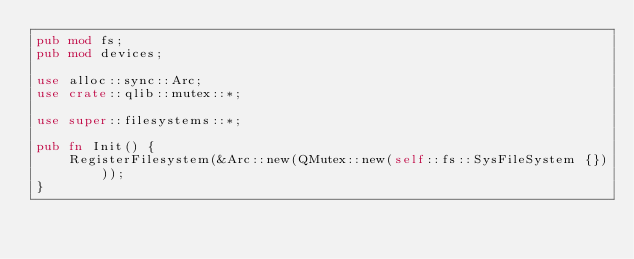Convert code to text. <code><loc_0><loc_0><loc_500><loc_500><_Rust_>pub mod fs;
pub mod devices;

use alloc::sync::Arc;
use crate::qlib::mutex::*;

use super::filesystems::*;

pub fn Init() {
    RegisterFilesystem(&Arc::new(QMutex::new(self::fs::SysFileSystem {})));
}</code> 